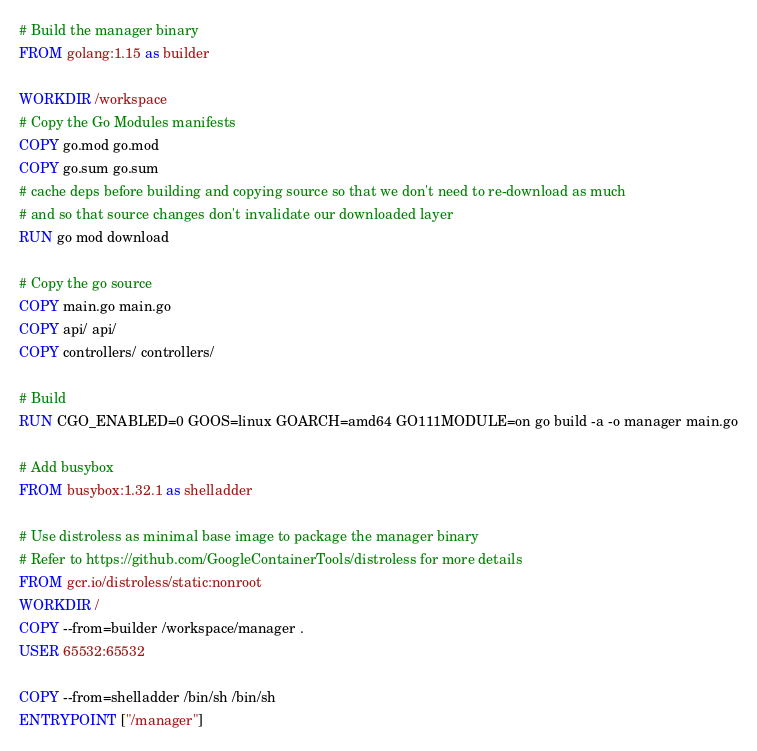Convert code to text. <code><loc_0><loc_0><loc_500><loc_500><_Dockerfile_># Build the manager binary
FROM golang:1.15 as builder

WORKDIR /workspace
# Copy the Go Modules manifests
COPY go.mod go.mod
COPY go.sum go.sum
# cache deps before building and copying source so that we don't need to re-download as much
# and so that source changes don't invalidate our downloaded layer
RUN go mod download

# Copy the go source
COPY main.go main.go
COPY api/ api/
COPY controllers/ controllers/

# Build
RUN CGO_ENABLED=0 GOOS=linux GOARCH=amd64 GO111MODULE=on go build -a -o manager main.go

# Add busybox
FROM busybox:1.32.1 as shelladder

# Use distroless as minimal base image to package the manager binary
# Refer to https://github.com/GoogleContainerTools/distroless for more details
FROM gcr.io/distroless/static:nonroot
WORKDIR /
COPY --from=builder /workspace/manager .
USER 65532:65532

COPY --from=shelladder /bin/sh /bin/sh
ENTRYPOINT ["/manager"]
</code> 